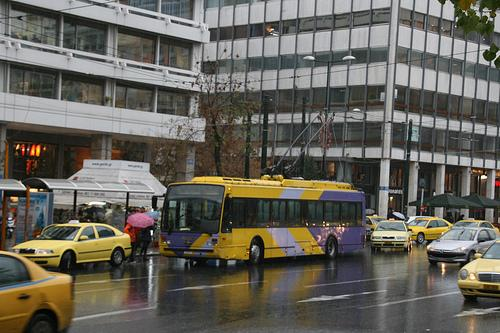Enumerate the types of transportation available in this urban setting. City bus, yellow taxis, and private cars are the types of transportation available. What is the main activity happening at the bus stop in the image? People are standing around the covered bus stop shelter, some holding umbrellas. Provide a short description of the primary objects and the scene in the image. A yellow and purple city bus and a yellow taxi are driving on a wet city street with buildings, trees, and several people carrying umbrellas near a bus stop. Considering the given information, what might be the weather condition in the image? Given the wet street and people carrying umbrellas, it is likely a rainy day. Mention the colors and types of umbrellas in the image. There are pink, black, and dark green patio umbrellas in the image. Analyze the overall quality of the image - is it clear or blurry? Are objects easily distinguishable? The image quality is clear, and the objects are easily distinguishable. In the image, discuss the interaction among the different objects or elements. People with umbrellas are waiting at the bus stop, the bus and taxis are driving, and the buildings provide a backdrop to the busy urban scene. How many wheels on the bus are visible and what color are they? Two black wheels of the bus are visible. Describe the emotions or feelings that the image might evoke. The image might evoke feelings of a busy, gloomy, and rainy day on a city street. Provide the total count of various vehicles on the street. There are five vehicles: a bus, three yellow taxis, and a small silver car. Describe the road condition. the road is wet Are there any interesting architectural details on the building in the picture? Yes, a window and part of the building are visible. What type of car is parked near the bus? A) Compact B) Sedan C) SUV D) Sports Car A) Compact and B) Sedan Is the building in the city blue and white? The building in the city is described as having a size and position, but not a color, so mentioning specific colors is misleading. Are there people walking on the roof of the large multi-story office building? No, it's not mentioned in the image. Is the yellow taxi cab flying in the sky? The taxis are described as driving or passing, but not flying, so this instruction is misleading. Describe the scene in the photo. A rainy day on a busy street with vehicles, bus stop, and people with umbrellas. What is on the street to indicate traffic direction? white arrow Can you spot a bus station cover in the photo? Yes, there is a covered bus stop shelter. What is the color of the building in this picture? multicolored Do you see a tree in the image? If so, provide a short description. Yes, there is a tall skinny tree. Identify the activity happening on the street. vehicles driving and people standing at the bus stop What type of car is driving on the road? silver sedan and small silver car Who is carrying a pink umbrella? a person in the photo What kind of umbrella is held by the person in the photo? pink umbrella What color are the umbrellas that are located on the sidewalk? dark green Is there a person carrying an orange umbrella? The umbrella mentioned in the image is pink, black, and there are two dark green patio umbrellas, but not orange, so this instruction is misleading. Can you find a green bus in the photo? The bus is described as blue and yellow, purple and yellow, and multicolored, but not green, so asking for a green bus is misleading. What objects can you see near the top of the tree? branches and leaves What is the color of the bus in the photo? blue and yellow Provide a brief narrative about the street in the photo. A busy, wet city street scene with a diverse array of vehicles and a covered bus stop with people holding umbrellas. Identify any key actions taking place between the taxi and the bus. yellow taxi passing the bus Can you see a red car in the photo? The cars are described as gray, silver, and small, but no car is described as being red, so this instruction is misleading. For the VQA, identify the primary color of the taxi in the photo. A) Blue B) Yellow C) Red D) Green B) Yellow What type of vehicle is picking up a passenger in the photo? yellow taxicab 